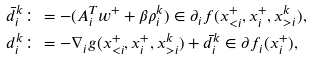<formula> <loc_0><loc_0><loc_500><loc_500>\bar { d } _ { i } ^ { k } & \colon = - ( A _ { i } ^ { T } w ^ { + } + \beta \rho _ { i } ^ { k } ) \in \partial _ { i } f ( x ^ { + } _ { < i } , x ^ { + } _ { i } , x ^ { k } _ { > i } ) , \\ d _ { i } ^ { k } & \colon = - \nabla _ { i } g ( x ^ { + } _ { < i } , x ^ { + } _ { i } , x ^ { k } _ { > i } ) + \bar { d } _ { i } ^ { k } \in \partial f _ { i } ( x ^ { + } _ { i } ) ,</formula> 